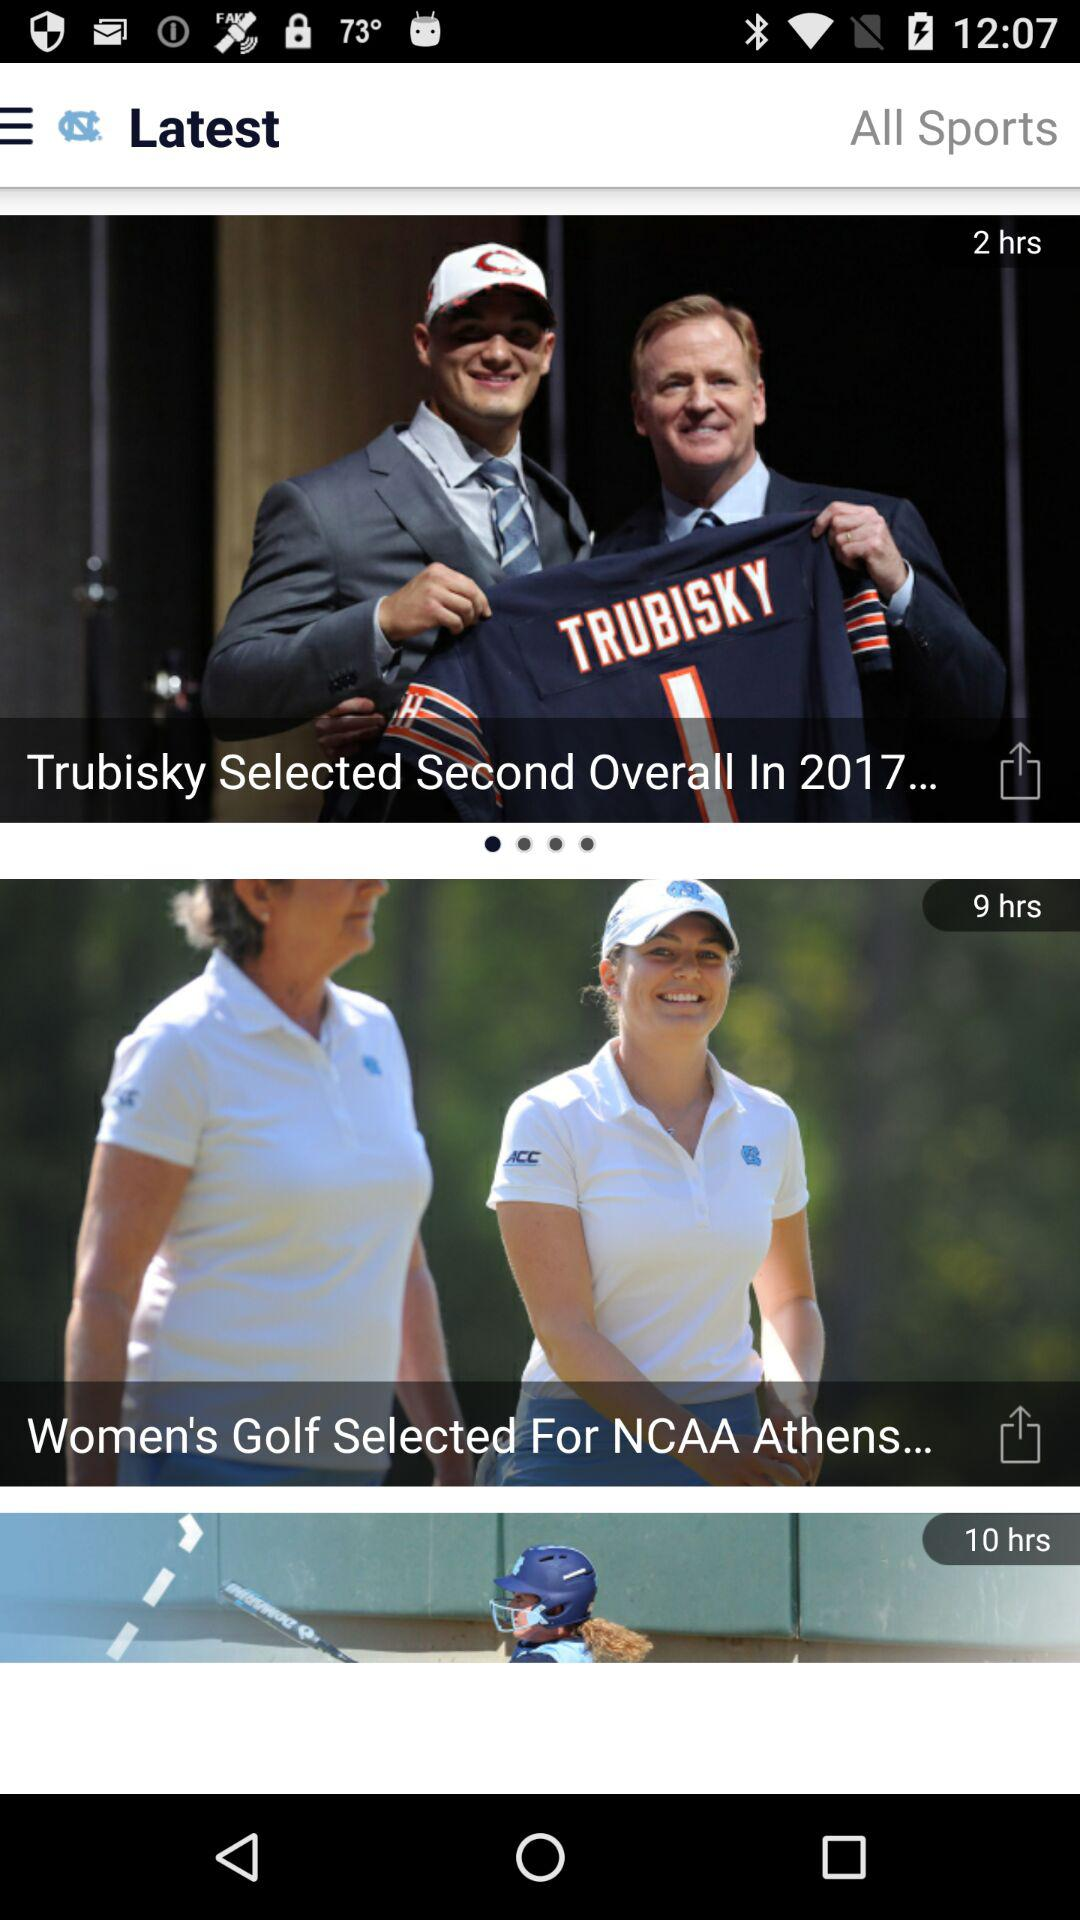When was the latest news updated?
When the provided information is insufficient, respond with <no answer>. <no answer> 